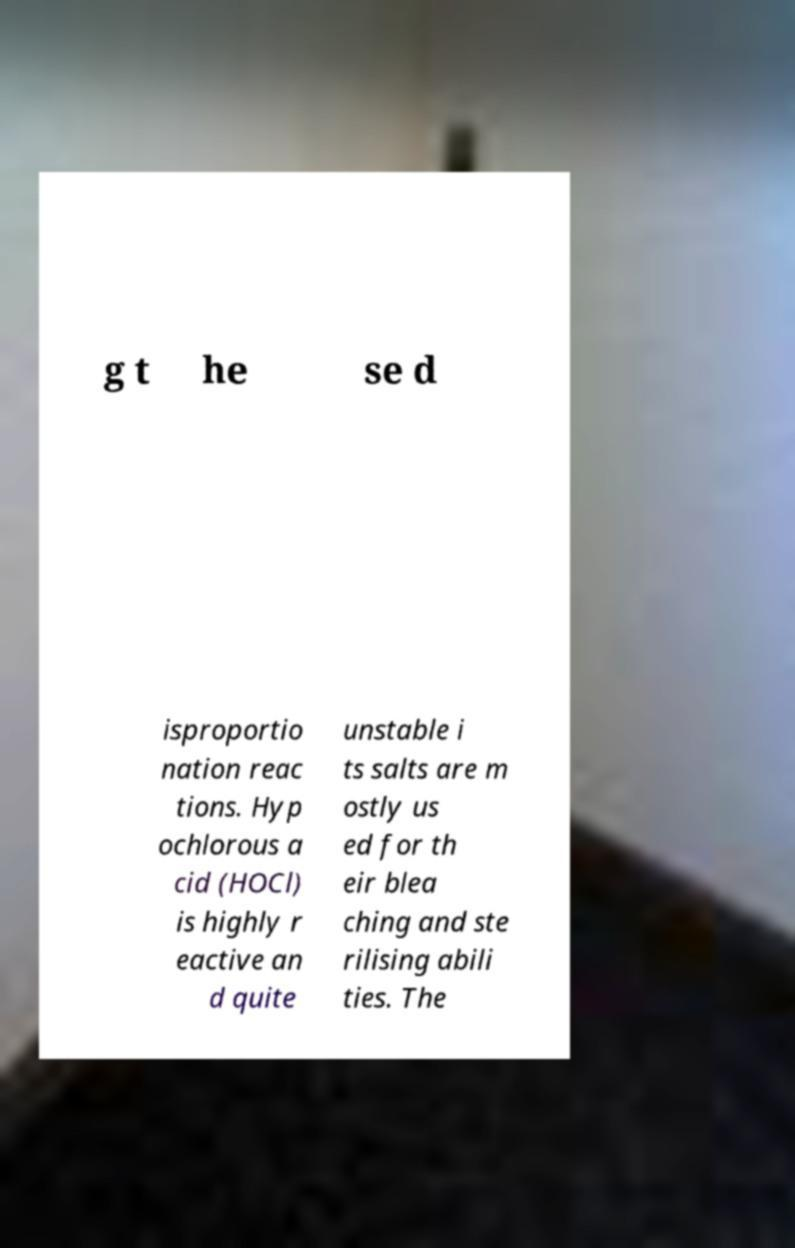Could you extract and type out the text from this image? g t he se d isproportio nation reac tions. Hyp ochlorous a cid (HOCl) is highly r eactive an d quite unstable i ts salts are m ostly us ed for th eir blea ching and ste rilising abili ties. The 